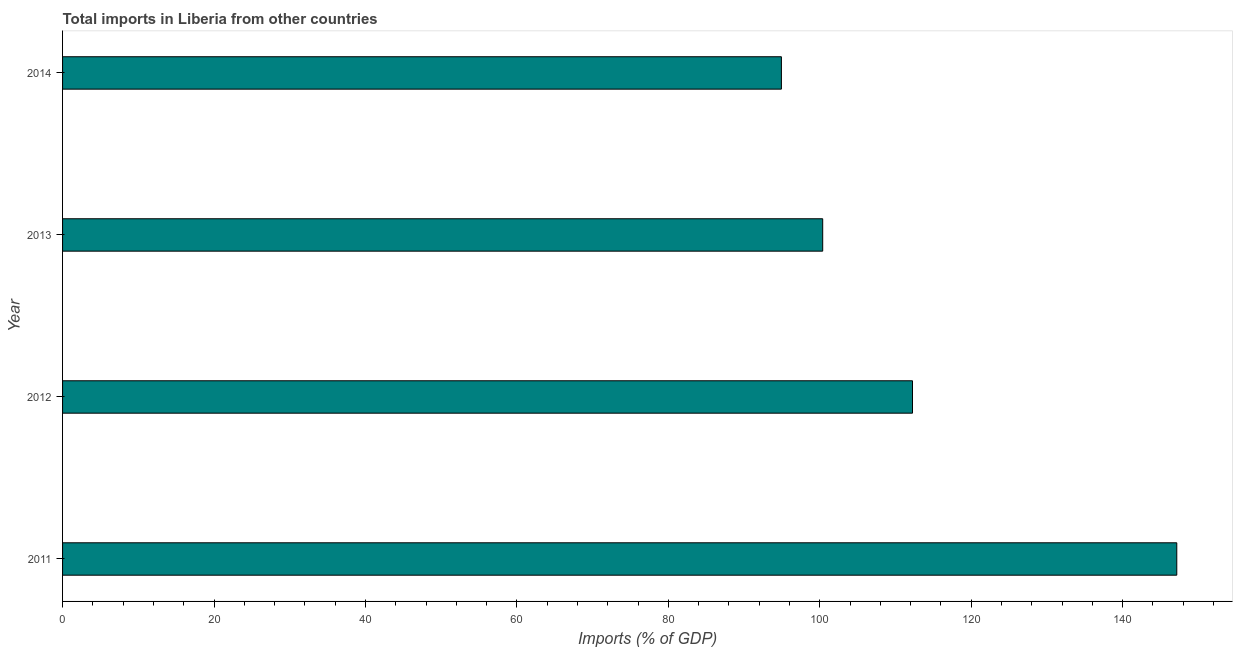Does the graph contain any zero values?
Provide a short and direct response. No. What is the title of the graph?
Your response must be concise. Total imports in Liberia from other countries. What is the label or title of the X-axis?
Provide a short and direct response. Imports (% of GDP). What is the label or title of the Y-axis?
Offer a terse response. Year. What is the total imports in 2012?
Ensure brevity in your answer.  112.24. Across all years, what is the maximum total imports?
Your response must be concise. 147.15. Across all years, what is the minimum total imports?
Your answer should be very brief. 94.93. What is the sum of the total imports?
Offer a very short reply. 454.71. What is the difference between the total imports in 2011 and 2013?
Make the answer very short. 46.76. What is the average total imports per year?
Your answer should be very brief. 113.68. What is the median total imports?
Offer a very short reply. 106.31. In how many years, is the total imports greater than 44 %?
Your response must be concise. 4. Do a majority of the years between 2014 and 2011 (inclusive) have total imports greater than 72 %?
Provide a succinct answer. Yes. What is the ratio of the total imports in 2013 to that in 2014?
Make the answer very short. 1.06. What is the difference between the highest and the second highest total imports?
Provide a succinct answer. 34.9. Is the sum of the total imports in 2011 and 2012 greater than the maximum total imports across all years?
Ensure brevity in your answer.  Yes. What is the difference between the highest and the lowest total imports?
Keep it short and to the point. 52.21. How many bars are there?
Provide a short and direct response. 4. What is the Imports (% of GDP) in 2011?
Keep it short and to the point. 147.15. What is the Imports (% of GDP) in 2012?
Your answer should be compact. 112.24. What is the Imports (% of GDP) of 2013?
Offer a terse response. 100.39. What is the Imports (% of GDP) of 2014?
Your response must be concise. 94.93. What is the difference between the Imports (% of GDP) in 2011 and 2012?
Keep it short and to the point. 34.9. What is the difference between the Imports (% of GDP) in 2011 and 2013?
Offer a very short reply. 46.76. What is the difference between the Imports (% of GDP) in 2011 and 2014?
Your answer should be compact. 52.21. What is the difference between the Imports (% of GDP) in 2012 and 2013?
Your answer should be very brief. 11.86. What is the difference between the Imports (% of GDP) in 2012 and 2014?
Provide a succinct answer. 17.31. What is the difference between the Imports (% of GDP) in 2013 and 2014?
Keep it short and to the point. 5.45. What is the ratio of the Imports (% of GDP) in 2011 to that in 2012?
Your answer should be very brief. 1.31. What is the ratio of the Imports (% of GDP) in 2011 to that in 2013?
Provide a short and direct response. 1.47. What is the ratio of the Imports (% of GDP) in 2011 to that in 2014?
Keep it short and to the point. 1.55. What is the ratio of the Imports (% of GDP) in 2012 to that in 2013?
Your response must be concise. 1.12. What is the ratio of the Imports (% of GDP) in 2012 to that in 2014?
Your answer should be very brief. 1.18. What is the ratio of the Imports (% of GDP) in 2013 to that in 2014?
Offer a very short reply. 1.06. 